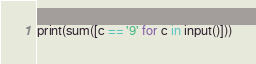<code> <loc_0><loc_0><loc_500><loc_500><_Python_>print(sum([c == '9' for c in input()]))</code> 